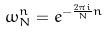<formula> <loc_0><loc_0><loc_500><loc_500>\omega _ { N } ^ { n } = e ^ { - \frac { 2 \pi i } { N } n }</formula> 